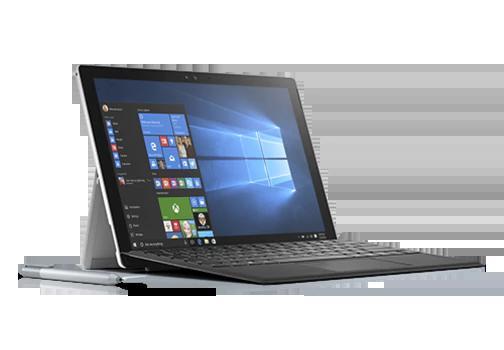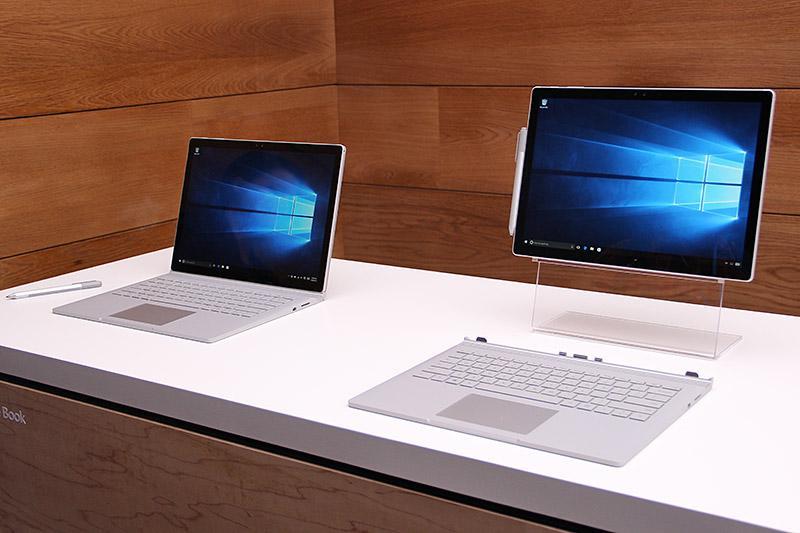The first image is the image on the left, the second image is the image on the right. Assess this claim about the two images: "Each image includes exactly one visible screen, and the screens in the left and right images face toward each other.". Correct or not? Answer yes or no. No. 